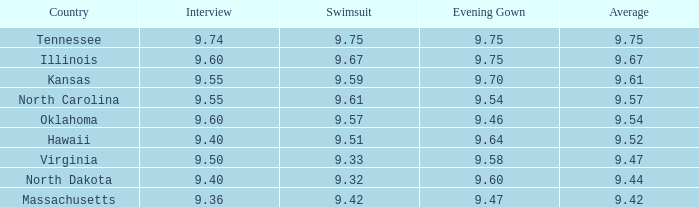Where was a 9.67 swimsuit score recorded in a country? Illinois. 